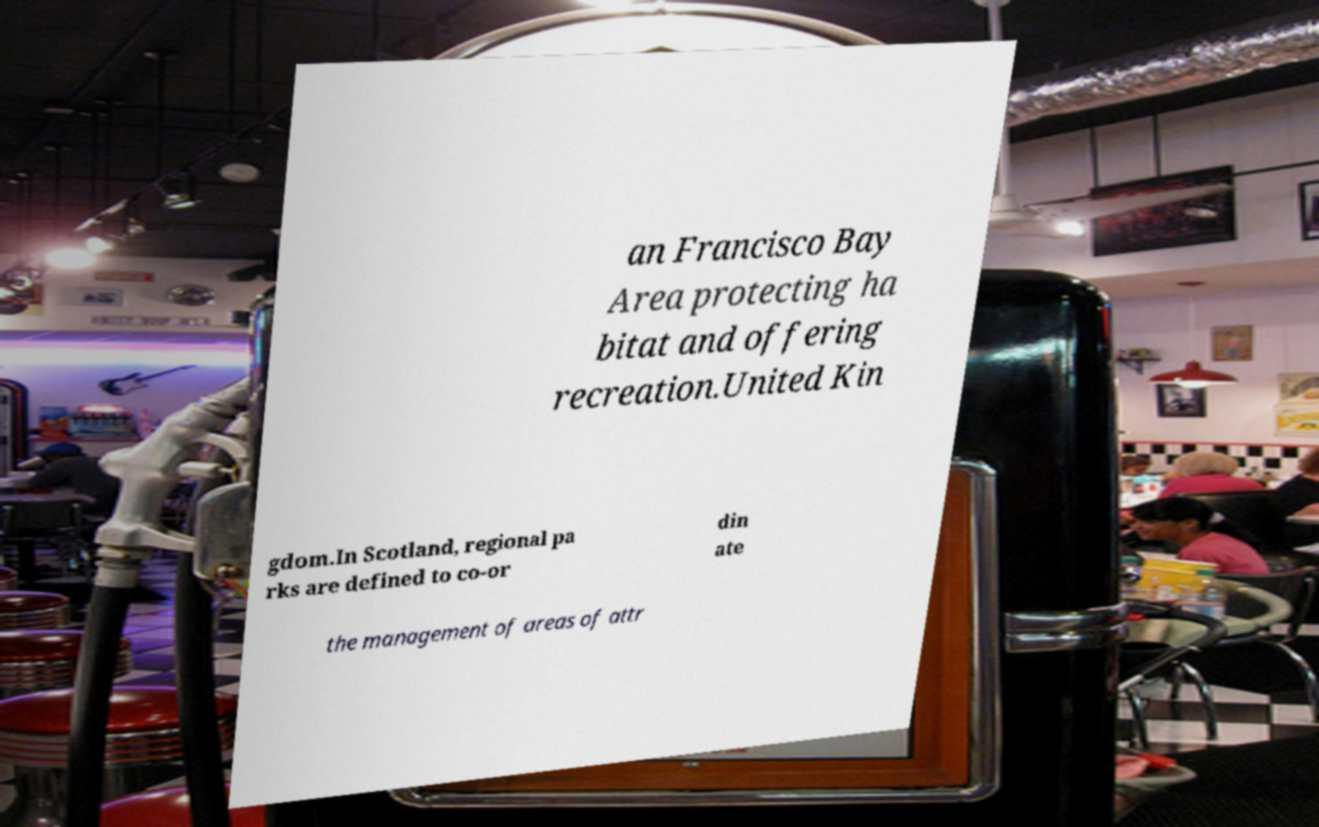Please identify and transcribe the text found in this image. an Francisco Bay Area protecting ha bitat and offering recreation.United Kin gdom.In Scotland, regional pa rks are defined to co-or din ate the management of areas of attr 